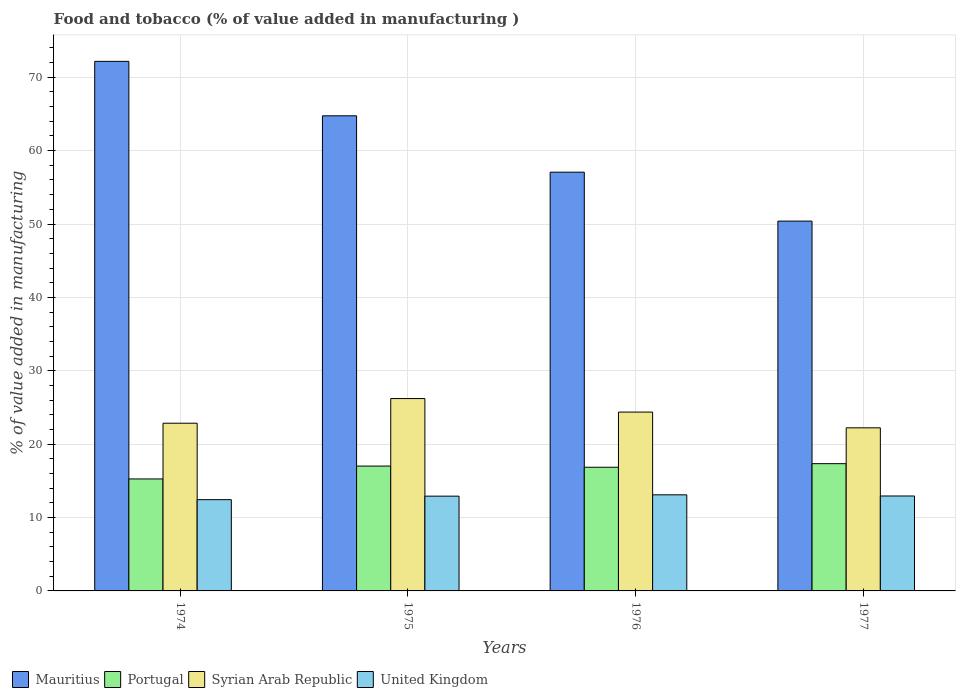How many groups of bars are there?
Provide a succinct answer. 4. Are the number of bars per tick equal to the number of legend labels?
Your response must be concise. Yes. How many bars are there on the 3rd tick from the left?
Your answer should be compact. 4. What is the label of the 4th group of bars from the left?
Your response must be concise. 1977. In how many cases, is the number of bars for a given year not equal to the number of legend labels?
Your answer should be very brief. 0. What is the value added in manufacturing food and tobacco in United Kingdom in 1975?
Provide a succinct answer. 12.92. Across all years, what is the maximum value added in manufacturing food and tobacco in United Kingdom?
Provide a succinct answer. 13.1. Across all years, what is the minimum value added in manufacturing food and tobacco in Mauritius?
Give a very brief answer. 50.4. In which year was the value added in manufacturing food and tobacco in Portugal maximum?
Give a very brief answer. 1977. In which year was the value added in manufacturing food and tobacco in Portugal minimum?
Offer a very short reply. 1974. What is the total value added in manufacturing food and tobacco in United Kingdom in the graph?
Your answer should be compact. 51.39. What is the difference between the value added in manufacturing food and tobacco in United Kingdom in 1974 and that in 1976?
Make the answer very short. -0.66. What is the difference between the value added in manufacturing food and tobacco in United Kingdom in 1977 and the value added in manufacturing food and tobacco in Syrian Arab Republic in 1976?
Provide a succinct answer. -11.43. What is the average value added in manufacturing food and tobacco in Syrian Arab Republic per year?
Your response must be concise. 23.92. In the year 1977, what is the difference between the value added in manufacturing food and tobacco in Mauritius and value added in manufacturing food and tobacco in Portugal?
Offer a terse response. 33.06. What is the ratio of the value added in manufacturing food and tobacco in Mauritius in 1975 to that in 1976?
Ensure brevity in your answer.  1.13. Is the difference between the value added in manufacturing food and tobacco in Mauritius in 1974 and 1976 greater than the difference between the value added in manufacturing food and tobacco in Portugal in 1974 and 1976?
Ensure brevity in your answer.  Yes. What is the difference between the highest and the second highest value added in manufacturing food and tobacco in Syrian Arab Republic?
Make the answer very short. 1.84. What is the difference between the highest and the lowest value added in manufacturing food and tobacco in Syrian Arab Republic?
Ensure brevity in your answer.  3.99. In how many years, is the value added in manufacturing food and tobacco in Mauritius greater than the average value added in manufacturing food and tobacco in Mauritius taken over all years?
Provide a succinct answer. 2. Is the sum of the value added in manufacturing food and tobacco in Syrian Arab Republic in 1974 and 1975 greater than the maximum value added in manufacturing food and tobacco in Mauritius across all years?
Make the answer very short. No. Is it the case that in every year, the sum of the value added in manufacturing food and tobacco in Mauritius and value added in manufacturing food and tobacco in Portugal is greater than the value added in manufacturing food and tobacco in Syrian Arab Republic?
Give a very brief answer. Yes. How many bars are there?
Your response must be concise. 16. What is the difference between two consecutive major ticks on the Y-axis?
Make the answer very short. 10. What is the title of the graph?
Make the answer very short. Food and tobacco (% of value added in manufacturing ). What is the label or title of the X-axis?
Your response must be concise. Years. What is the label or title of the Y-axis?
Keep it short and to the point. % of value added in manufacturing. What is the % of value added in manufacturing of Mauritius in 1974?
Keep it short and to the point. 72.17. What is the % of value added in manufacturing of Portugal in 1974?
Make the answer very short. 15.26. What is the % of value added in manufacturing in Syrian Arab Republic in 1974?
Your answer should be very brief. 22.85. What is the % of value added in manufacturing in United Kingdom in 1974?
Keep it short and to the point. 12.44. What is the % of value added in manufacturing in Mauritius in 1975?
Give a very brief answer. 64.75. What is the % of value added in manufacturing in Portugal in 1975?
Your answer should be very brief. 17.01. What is the % of value added in manufacturing in Syrian Arab Republic in 1975?
Your answer should be very brief. 26.21. What is the % of value added in manufacturing in United Kingdom in 1975?
Your answer should be compact. 12.92. What is the % of value added in manufacturing of Mauritius in 1976?
Your response must be concise. 57.07. What is the % of value added in manufacturing in Portugal in 1976?
Make the answer very short. 16.85. What is the % of value added in manufacturing in Syrian Arab Republic in 1976?
Give a very brief answer. 24.37. What is the % of value added in manufacturing in United Kingdom in 1976?
Your response must be concise. 13.1. What is the % of value added in manufacturing of Mauritius in 1977?
Offer a very short reply. 50.4. What is the % of value added in manufacturing of Portugal in 1977?
Make the answer very short. 17.34. What is the % of value added in manufacturing of Syrian Arab Republic in 1977?
Your answer should be compact. 22.23. What is the % of value added in manufacturing in United Kingdom in 1977?
Your response must be concise. 12.94. Across all years, what is the maximum % of value added in manufacturing in Mauritius?
Ensure brevity in your answer.  72.17. Across all years, what is the maximum % of value added in manufacturing of Portugal?
Your answer should be compact. 17.34. Across all years, what is the maximum % of value added in manufacturing of Syrian Arab Republic?
Provide a short and direct response. 26.21. Across all years, what is the maximum % of value added in manufacturing in United Kingdom?
Provide a short and direct response. 13.1. Across all years, what is the minimum % of value added in manufacturing in Mauritius?
Provide a short and direct response. 50.4. Across all years, what is the minimum % of value added in manufacturing of Portugal?
Ensure brevity in your answer.  15.26. Across all years, what is the minimum % of value added in manufacturing in Syrian Arab Republic?
Offer a very short reply. 22.23. Across all years, what is the minimum % of value added in manufacturing of United Kingdom?
Keep it short and to the point. 12.44. What is the total % of value added in manufacturing in Mauritius in the graph?
Your answer should be very brief. 244.38. What is the total % of value added in manufacturing in Portugal in the graph?
Provide a short and direct response. 66.47. What is the total % of value added in manufacturing of Syrian Arab Republic in the graph?
Your answer should be very brief. 95.67. What is the total % of value added in manufacturing in United Kingdom in the graph?
Make the answer very short. 51.39. What is the difference between the % of value added in manufacturing in Mauritius in 1974 and that in 1975?
Offer a very short reply. 7.42. What is the difference between the % of value added in manufacturing in Portugal in 1974 and that in 1975?
Your answer should be compact. -1.76. What is the difference between the % of value added in manufacturing of Syrian Arab Republic in 1974 and that in 1975?
Provide a short and direct response. -3.36. What is the difference between the % of value added in manufacturing in United Kingdom in 1974 and that in 1975?
Provide a succinct answer. -0.48. What is the difference between the % of value added in manufacturing of Mauritius in 1974 and that in 1976?
Your answer should be very brief. 15.1. What is the difference between the % of value added in manufacturing in Portugal in 1974 and that in 1976?
Offer a terse response. -1.6. What is the difference between the % of value added in manufacturing in Syrian Arab Republic in 1974 and that in 1976?
Offer a very short reply. -1.52. What is the difference between the % of value added in manufacturing in United Kingdom in 1974 and that in 1976?
Your answer should be very brief. -0.66. What is the difference between the % of value added in manufacturing of Mauritius in 1974 and that in 1977?
Make the answer very short. 21.77. What is the difference between the % of value added in manufacturing in Portugal in 1974 and that in 1977?
Provide a short and direct response. -2.08. What is the difference between the % of value added in manufacturing of Syrian Arab Republic in 1974 and that in 1977?
Your response must be concise. 0.63. What is the difference between the % of value added in manufacturing in United Kingdom in 1974 and that in 1977?
Provide a succinct answer. -0.5. What is the difference between the % of value added in manufacturing in Mauritius in 1975 and that in 1976?
Your response must be concise. 7.68. What is the difference between the % of value added in manufacturing of Portugal in 1975 and that in 1976?
Give a very brief answer. 0.16. What is the difference between the % of value added in manufacturing of Syrian Arab Republic in 1975 and that in 1976?
Offer a terse response. 1.84. What is the difference between the % of value added in manufacturing in United Kingdom in 1975 and that in 1976?
Your response must be concise. -0.18. What is the difference between the % of value added in manufacturing of Mauritius in 1975 and that in 1977?
Offer a very short reply. 14.35. What is the difference between the % of value added in manufacturing of Portugal in 1975 and that in 1977?
Provide a short and direct response. -0.33. What is the difference between the % of value added in manufacturing of Syrian Arab Republic in 1975 and that in 1977?
Your response must be concise. 3.99. What is the difference between the % of value added in manufacturing in United Kingdom in 1975 and that in 1977?
Keep it short and to the point. -0.02. What is the difference between the % of value added in manufacturing of Mauritius in 1976 and that in 1977?
Ensure brevity in your answer.  6.67. What is the difference between the % of value added in manufacturing of Portugal in 1976 and that in 1977?
Your response must be concise. -0.49. What is the difference between the % of value added in manufacturing in Syrian Arab Republic in 1976 and that in 1977?
Offer a very short reply. 2.14. What is the difference between the % of value added in manufacturing of United Kingdom in 1976 and that in 1977?
Provide a succinct answer. 0.16. What is the difference between the % of value added in manufacturing of Mauritius in 1974 and the % of value added in manufacturing of Portugal in 1975?
Keep it short and to the point. 55.15. What is the difference between the % of value added in manufacturing of Mauritius in 1974 and the % of value added in manufacturing of Syrian Arab Republic in 1975?
Offer a terse response. 45.96. What is the difference between the % of value added in manufacturing in Mauritius in 1974 and the % of value added in manufacturing in United Kingdom in 1975?
Your response must be concise. 59.25. What is the difference between the % of value added in manufacturing in Portugal in 1974 and the % of value added in manufacturing in Syrian Arab Republic in 1975?
Offer a terse response. -10.95. What is the difference between the % of value added in manufacturing of Portugal in 1974 and the % of value added in manufacturing of United Kingdom in 1975?
Your answer should be compact. 2.34. What is the difference between the % of value added in manufacturing in Syrian Arab Republic in 1974 and the % of value added in manufacturing in United Kingdom in 1975?
Make the answer very short. 9.94. What is the difference between the % of value added in manufacturing of Mauritius in 1974 and the % of value added in manufacturing of Portugal in 1976?
Your answer should be compact. 55.31. What is the difference between the % of value added in manufacturing in Mauritius in 1974 and the % of value added in manufacturing in Syrian Arab Republic in 1976?
Offer a terse response. 47.8. What is the difference between the % of value added in manufacturing in Mauritius in 1974 and the % of value added in manufacturing in United Kingdom in 1976?
Ensure brevity in your answer.  59.07. What is the difference between the % of value added in manufacturing of Portugal in 1974 and the % of value added in manufacturing of Syrian Arab Republic in 1976?
Ensure brevity in your answer.  -9.11. What is the difference between the % of value added in manufacturing in Portugal in 1974 and the % of value added in manufacturing in United Kingdom in 1976?
Offer a very short reply. 2.16. What is the difference between the % of value added in manufacturing in Syrian Arab Republic in 1974 and the % of value added in manufacturing in United Kingdom in 1976?
Make the answer very short. 9.76. What is the difference between the % of value added in manufacturing of Mauritius in 1974 and the % of value added in manufacturing of Portugal in 1977?
Offer a very short reply. 54.83. What is the difference between the % of value added in manufacturing of Mauritius in 1974 and the % of value added in manufacturing of Syrian Arab Republic in 1977?
Give a very brief answer. 49.94. What is the difference between the % of value added in manufacturing of Mauritius in 1974 and the % of value added in manufacturing of United Kingdom in 1977?
Provide a succinct answer. 59.23. What is the difference between the % of value added in manufacturing in Portugal in 1974 and the % of value added in manufacturing in Syrian Arab Republic in 1977?
Provide a short and direct response. -6.97. What is the difference between the % of value added in manufacturing of Portugal in 1974 and the % of value added in manufacturing of United Kingdom in 1977?
Ensure brevity in your answer.  2.32. What is the difference between the % of value added in manufacturing of Syrian Arab Republic in 1974 and the % of value added in manufacturing of United Kingdom in 1977?
Your answer should be very brief. 9.92. What is the difference between the % of value added in manufacturing of Mauritius in 1975 and the % of value added in manufacturing of Portugal in 1976?
Keep it short and to the point. 47.89. What is the difference between the % of value added in manufacturing of Mauritius in 1975 and the % of value added in manufacturing of Syrian Arab Republic in 1976?
Make the answer very short. 40.38. What is the difference between the % of value added in manufacturing of Mauritius in 1975 and the % of value added in manufacturing of United Kingdom in 1976?
Provide a succinct answer. 51.65. What is the difference between the % of value added in manufacturing in Portugal in 1975 and the % of value added in manufacturing in Syrian Arab Republic in 1976?
Keep it short and to the point. -7.36. What is the difference between the % of value added in manufacturing in Portugal in 1975 and the % of value added in manufacturing in United Kingdom in 1976?
Offer a terse response. 3.92. What is the difference between the % of value added in manufacturing in Syrian Arab Republic in 1975 and the % of value added in manufacturing in United Kingdom in 1976?
Provide a short and direct response. 13.12. What is the difference between the % of value added in manufacturing in Mauritius in 1975 and the % of value added in manufacturing in Portugal in 1977?
Provide a short and direct response. 47.41. What is the difference between the % of value added in manufacturing in Mauritius in 1975 and the % of value added in manufacturing in Syrian Arab Republic in 1977?
Offer a terse response. 42.52. What is the difference between the % of value added in manufacturing of Mauritius in 1975 and the % of value added in manufacturing of United Kingdom in 1977?
Provide a short and direct response. 51.81. What is the difference between the % of value added in manufacturing in Portugal in 1975 and the % of value added in manufacturing in Syrian Arab Republic in 1977?
Provide a succinct answer. -5.21. What is the difference between the % of value added in manufacturing of Portugal in 1975 and the % of value added in manufacturing of United Kingdom in 1977?
Offer a terse response. 4.08. What is the difference between the % of value added in manufacturing in Syrian Arab Republic in 1975 and the % of value added in manufacturing in United Kingdom in 1977?
Provide a short and direct response. 13.28. What is the difference between the % of value added in manufacturing of Mauritius in 1976 and the % of value added in manufacturing of Portugal in 1977?
Provide a succinct answer. 39.72. What is the difference between the % of value added in manufacturing in Mauritius in 1976 and the % of value added in manufacturing in Syrian Arab Republic in 1977?
Provide a succinct answer. 34.84. What is the difference between the % of value added in manufacturing in Mauritius in 1976 and the % of value added in manufacturing in United Kingdom in 1977?
Provide a succinct answer. 44.13. What is the difference between the % of value added in manufacturing in Portugal in 1976 and the % of value added in manufacturing in Syrian Arab Republic in 1977?
Provide a short and direct response. -5.37. What is the difference between the % of value added in manufacturing in Portugal in 1976 and the % of value added in manufacturing in United Kingdom in 1977?
Keep it short and to the point. 3.92. What is the difference between the % of value added in manufacturing in Syrian Arab Republic in 1976 and the % of value added in manufacturing in United Kingdom in 1977?
Give a very brief answer. 11.43. What is the average % of value added in manufacturing of Mauritius per year?
Ensure brevity in your answer.  61.09. What is the average % of value added in manufacturing of Portugal per year?
Ensure brevity in your answer.  16.62. What is the average % of value added in manufacturing of Syrian Arab Republic per year?
Ensure brevity in your answer.  23.92. What is the average % of value added in manufacturing of United Kingdom per year?
Offer a very short reply. 12.85. In the year 1974, what is the difference between the % of value added in manufacturing in Mauritius and % of value added in manufacturing in Portugal?
Offer a very short reply. 56.91. In the year 1974, what is the difference between the % of value added in manufacturing of Mauritius and % of value added in manufacturing of Syrian Arab Republic?
Offer a terse response. 49.31. In the year 1974, what is the difference between the % of value added in manufacturing in Mauritius and % of value added in manufacturing in United Kingdom?
Give a very brief answer. 59.73. In the year 1974, what is the difference between the % of value added in manufacturing in Portugal and % of value added in manufacturing in Syrian Arab Republic?
Make the answer very short. -7.6. In the year 1974, what is the difference between the % of value added in manufacturing of Portugal and % of value added in manufacturing of United Kingdom?
Provide a succinct answer. 2.82. In the year 1974, what is the difference between the % of value added in manufacturing of Syrian Arab Republic and % of value added in manufacturing of United Kingdom?
Provide a short and direct response. 10.42. In the year 1975, what is the difference between the % of value added in manufacturing in Mauritius and % of value added in manufacturing in Portugal?
Give a very brief answer. 47.73. In the year 1975, what is the difference between the % of value added in manufacturing in Mauritius and % of value added in manufacturing in Syrian Arab Republic?
Give a very brief answer. 38.53. In the year 1975, what is the difference between the % of value added in manufacturing of Mauritius and % of value added in manufacturing of United Kingdom?
Keep it short and to the point. 51.83. In the year 1975, what is the difference between the % of value added in manufacturing in Portugal and % of value added in manufacturing in Syrian Arab Republic?
Ensure brevity in your answer.  -9.2. In the year 1975, what is the difference between the % of value added in manufacturing in Portugal and % of value added in manufacturing in United Kingdom?
Your response must be concise. 4.1. In the year 1975, what is the difference between the % of value added in manufacturing of Syrian Arab Republic and % of value added in manufacturing of United Kingdom?
Make the answer very short. 13.3. In the year 1976, what is the difference between the % of value added in manufacturing in Mauritius and % of value added in manufacturing in Portugal?
Provide a short and direct response. 40.21. In the year 1976, what is the difference between the % of value added in manufacturing in Mauritius and % of value added in manufacturing in Syrian Arab Republic?
Ensure brevity in your answer.  32.69. In the year 1976, what is the difference between the % of value added in manufacturing of Mauritius and % of value added in manufacturing of United Kingdom?
Provide a short and direct response. 43.97. In the year 1976, what is the difference between the % of value added in manufacturing of Portugal and % of value added in manufacturing of Syrian Arab Republic?
Provide a short and direct response. -7.52. In the year 1976, what is the difference between the % of value added in manufacturing of Portugal and % of value added in manufacturing of United Kingdom?
Provide a short and direct response. 3.76. In the year 1976, what is the difference between the % of value added in manufacturing in Syrian Arab Republic and % of value added in manufacturing in United Kingdom?
Give a very brief answer. 11.27. In the year 1977, what is the difference between the % of value added in manufacturing of Mauritius and % of value added in manufacturing of Portugal?
Your response must be concise. 33.06. In the year 1977, what is the difference between the % of value added in manufacturing of Mauritius and % of value added in manufacturing of Syrian Arab Republic?
Offer a terse response. 28.17. In the year 1977, what is the difference between the % of value added in manufacturing in Mauritius and % of value added in manufacturing in United Kingdom?
Keep it short and to the point. 37.46. In the year 1977, what is the difference between the % of value added in manufacturing in Portugal and % of value added in manufacturing in Syrian Arab Republic?
Offer a very short reply. -4.89. In the year 1977, what is the difference between the % of value added in manufacturing in Portugal and % of value added in manufacturing in United Kingdom?
Your answer should be compact. 4.4. In the year 1977, what is the difference between the % of value added in manufacturing of Syrian Arab Republic and % of value added in manufacturing of United Kingdom?
Give a very brief answer. 9.29. What is the ratio of the % of value added in manufacturing in Mauritius in 1974 to that in 1975?
Keep it short and to the point. 1.11. What is the ratio of the % of value added in manufacturing of Portugal in 1974 to that in 1975?
Provide a succinct answer. 0.9. What is the ratio of the % of value added in manufacturing of Syrian Arab Republic in 1974 to that in 1975?
Offer a very short reply. 0.87. What is the ratio of the % of value added in manufacturing in United Kingdom in 1974 to that in 1975?
Keep it short and to the point. 0.96. What is the ratio of the % of value added in manufacturing of Mauritius in 1974 to that in 1976?
Offer a terse response. 1.26. What is the ratio of the % of value added in manufacturing of Portugal in 1974 to that in 1976?
Your response must be concise. 0.91. What is the ratio of the % of value added in manufacturing in Syrian Arab Republic in 1974 to that in 1976?
Give a very brief answer. 0.94. What is the ratio of the % of value added in manufacturing in United Kingdom in 1974 to that in 1976?
Give a very brief answer. 0.95. What is the ratio of the % of value added in manufacturing in Mauritius in 1974 to that in 1977?
Keep it short and to the point. 1.43. What is the ratio of the % of value added in manufacturing in Portugal in 1974 to that in 1977?
Give a very brief answer. 0.88. What is the ratio of the % of value added in manufacturing in Syrian Arab Republic in 1974 to that in 1977?
Provide a short and direct response. 1.03. What is the ratio of the % of value added in manufacturing in United Kingdom in 1974 to that in 1977?
Offer a very short reply. 0.96. What is the ratio of the % of value added in manufacturing of Mauritius in 1975 to that in 1976?
Give a very brief answer. 1.13. What is the ratio of the % of value added in manufacturing in Portugal in 1975 to that in 1976?
Give a very brief answer. 1.01. What is the ratio of the % of value added in manufacturing in Syrian Arab Republic in 1975 to that in 1976?
Give a very brief answer. 1.08. What is the ratio of the % of value added in manufacturing of United Kingdom in 1975 to that in 1976?
Your answer should be very brief. 0.99. What is the ratio of the % of value added in manufacturing in Mauritius in 1975 to that in 1977?
Make the answer very short. 1.28. What is the ratio of the % of value added in manufacturing in Portugal in 1975 to that in 1977?
Your response must be concise. 0.98. What is the ratio of the % of value added in manufacturing of Syrian Arab Republic in 1975 to that in 1977?
Make the answer very short. 1.18. What is the ratio of the % of value added in manufacturing in United Kingdom in 1975 to that in 1977?
Offer a very short reply. 1. What is the ratio of the % of value added in manufacturing in Mauritius in 1976 to that in 1977?
Keep it short and to the point. 1.13. What is the ratio of the % of value added in manufacturing of Portugal in 1976 to that in 1977?
Offer a very short reply. 0.97. What is the ratio of the % of value added in manufacturing of Syrian Arab Republic in 1976 to that in 1977?
Make the answer very short. 1.1. What is the ratio of the % of value added in manufacturing of United Kingdom in 1976 to that in 1977?
Your answer should be compact. 1.01. What is the difference between the highest and the second highest % of value added in manufacturing of Mauritius?
Your response must be concise. 7.42. What is the difference between the highest and the second highest % of value added in manufacturing in Portugal?
Your response must be concise. 0.33. What is the difference between the highest and the second highest % of value added in manufacturing of Syrian Arab Republic?
Make the answer very short. 1.84. What is the difference between the highest and the second highest % of value added in manufacturing of United Kingdom?
Your response must be concise. 0.16. What is the difference between the highest and the lowest % of value added in manufacturing of Mauritius?
Offer a terse response. 21.77. What is the difference between the highest and the lowest % of value added in manufacturing in Portugal?
Give a very brief answer. 2.08. What is the difference between the highest and the lowest % of value added in manufacturing of Syrian Arab Republic?
Ensure brevity in your answer.  3.99. What is the difference between the highest and the lowest % of value added in manufacturing of United Kingdom?
Offer a terse response. 0.66. 